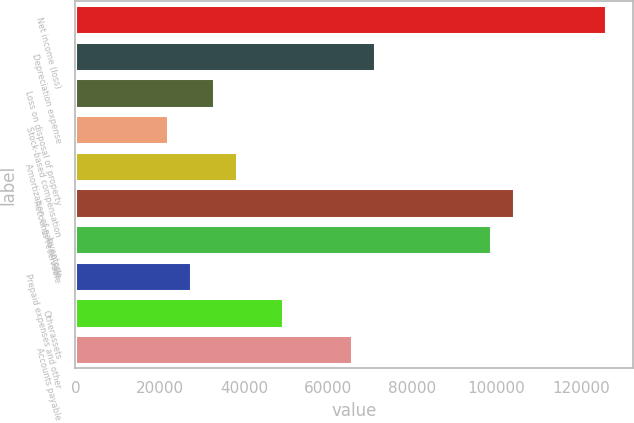<chart> <loc_0><loc_0><loc_500><loc_500><bar_chart><fcel>Net income (loss)<fcel>Depreciation expense<fcel>Loss on disposal of property<fcel>Stock-based compensation<fcel>Amortization of gain on sale<fcel>Accounts receivable<fcel>Inventory<fcel>Prepaid expenses and other<fcel>Otherassets<fcel>Accounts payable<nl><fcel>125995<fcel>71221.2<fcel>32879.4<fcel>21924.6<fcel>38356.8<fcel>104086<fcel>98608.2<fcel>27402<fcel>49311.6<fcel>65743.8<nl></chart> 